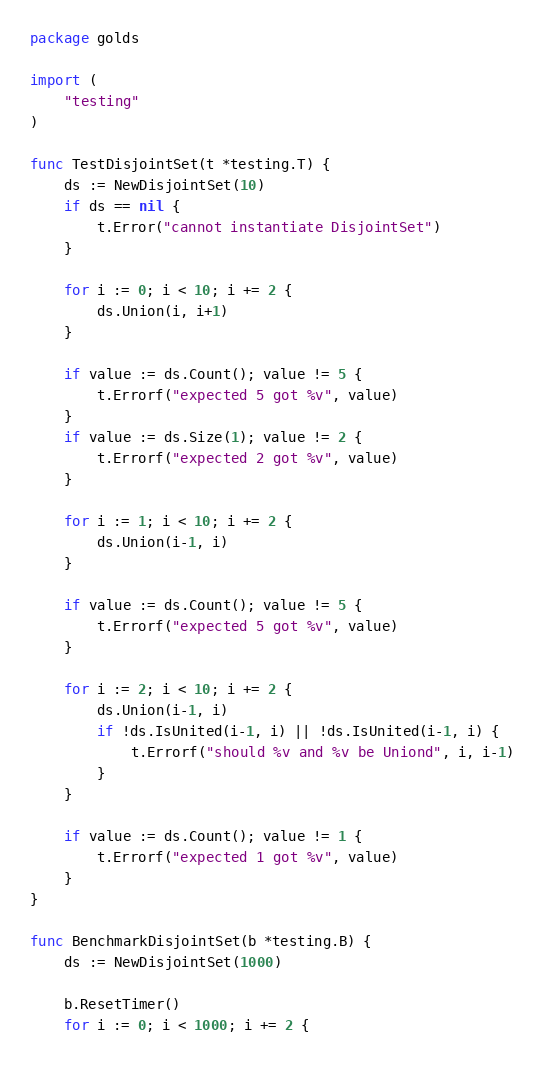<code> <loc_0><loc_0><loc_500><loc_500><_Go_>package golds

import (
	"testing"
)

func TestDisjointSet(t *testing.T) {
	ds := NewDisjointSet(10)
	if ds == nil {
		t.Error("cannot instantiate DisjointSet")
	}

	for i := 0; i < 10; i += 2 {
		ds.Union(i, i+1)
	}

	if value := ds.Count(); value != 5 {
		t.Errorf("expected 5 got %v", value)
	}
	if value := ds.Size(1); value != 2 {
		t.Errorf("expected 2 got %v", value)
	}

	for i := 1; i < 10; i += 2 {
		ds.Union(i-1, i)
	}

	if value := ds.Count(); value != 5 {
		t.Errorf("expected 5 got %v", value)
	}

	for i := 2; i < 10; i += 2 {
		ds.Union(i-1, i)
		if !ds.IsUnited(i-1, i) || !ds.IsUnited(i-1, i) {
			t.Errorf("should %v and %v be Uniond", i, i-1)
		}
	}

	if value := ds.Count(); value != 1 {
		t.Errorf("expected 1 got %v", value)
	}
}

func BenchmarkDisjointSet(b *testing.B) {
	ds := NewDisjointSet(1000)

	b.ResetTimer()
	for i := 0; i < 1000; i += 2 {</code> 